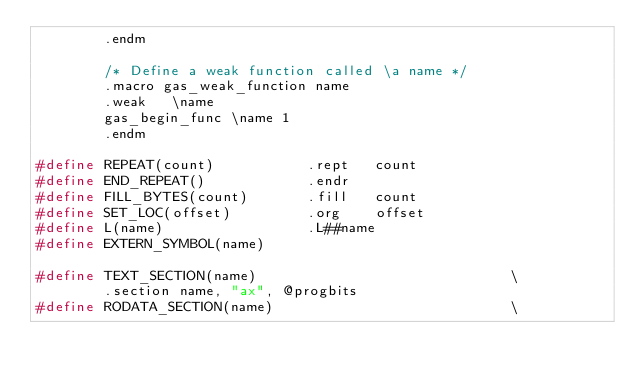<code> <loc_0><loc_0><loc_500><loc_500><_C_>        .endm

        /* Define a weak function called \a name */
        .macro gas_weak_function name
        .weak   \name
        gas_begin_func \name 1
        .endm

#define REPEAT(count)           .rept   count
#define END_REPEAT()            .endr
#define FILL_BYTES(count)       .fill   count
#define SET_LOC(offset)         .org    offset
#define L(name)                 .L##name
#define EXTERN_SYMBOL(name)

#define TEXT_SECTION(name)                              \
        .section name, "ax", @progbits
#define RODATA_SECTION(name)                            \</code> 